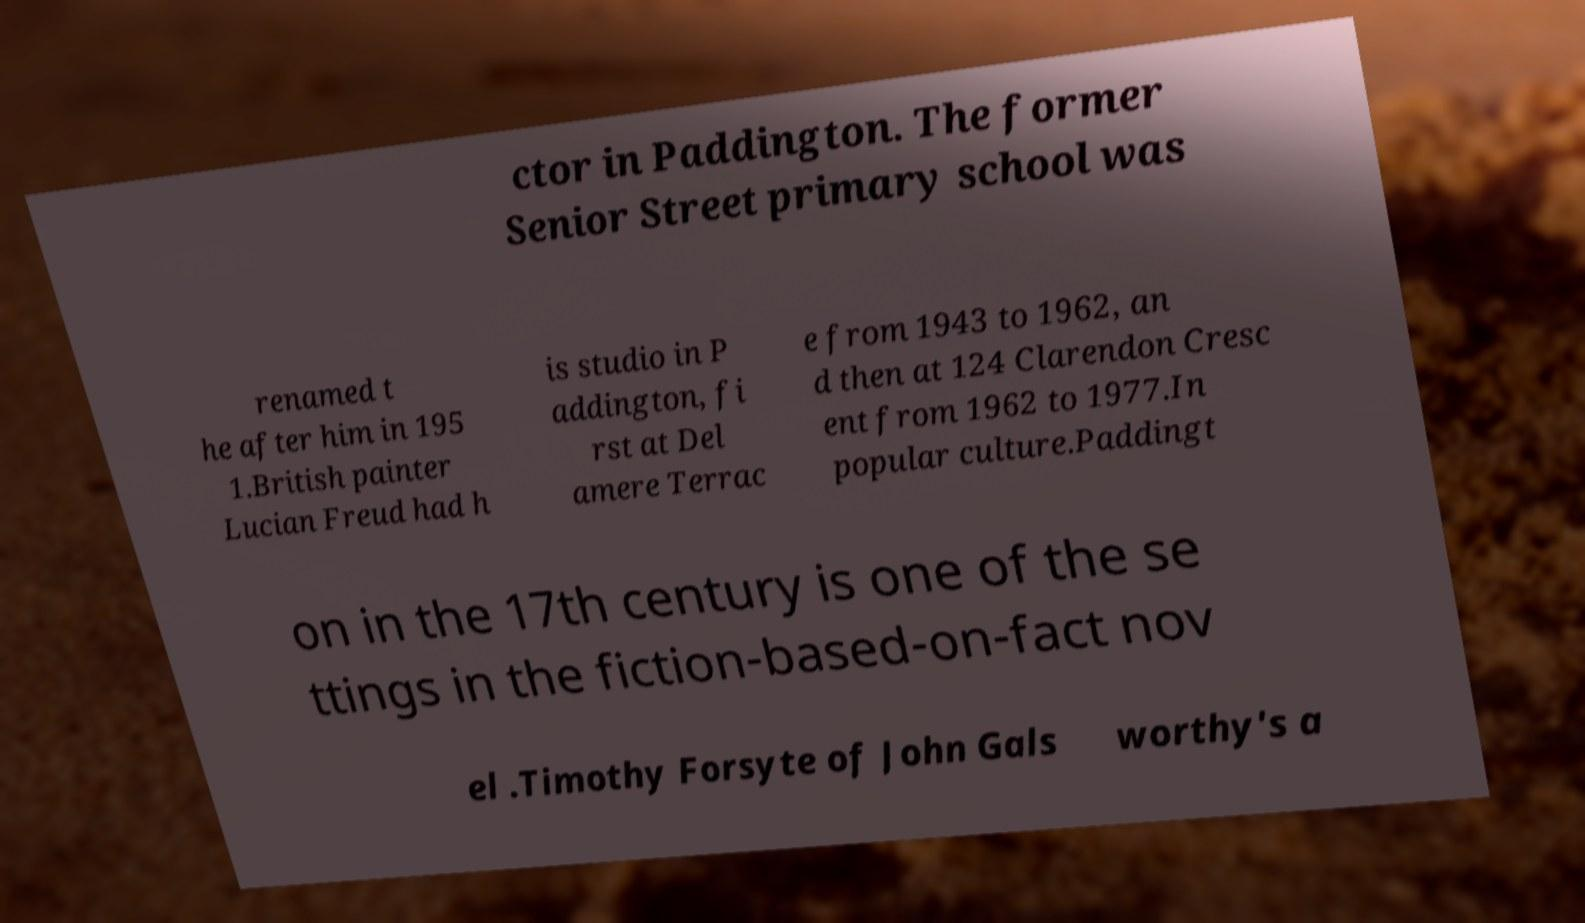I need the written content from this picture converted into text. Can you do that? ctor in Paddington. The former Senior Street primary school was renamed t he after him in 195 1.British painter Lucian Freud had h is studio in P addington, fi rst at Del amere Terrac e from 1943 to 1962, an d then at 124 Clarendon Cresc ent from 1962 to 1977.In popular culture.Paddingt on in the 17th century is one of the se ttings in the fiction-based-on-fact nov el .Timothy Forsyte of John Gals worthy's a 